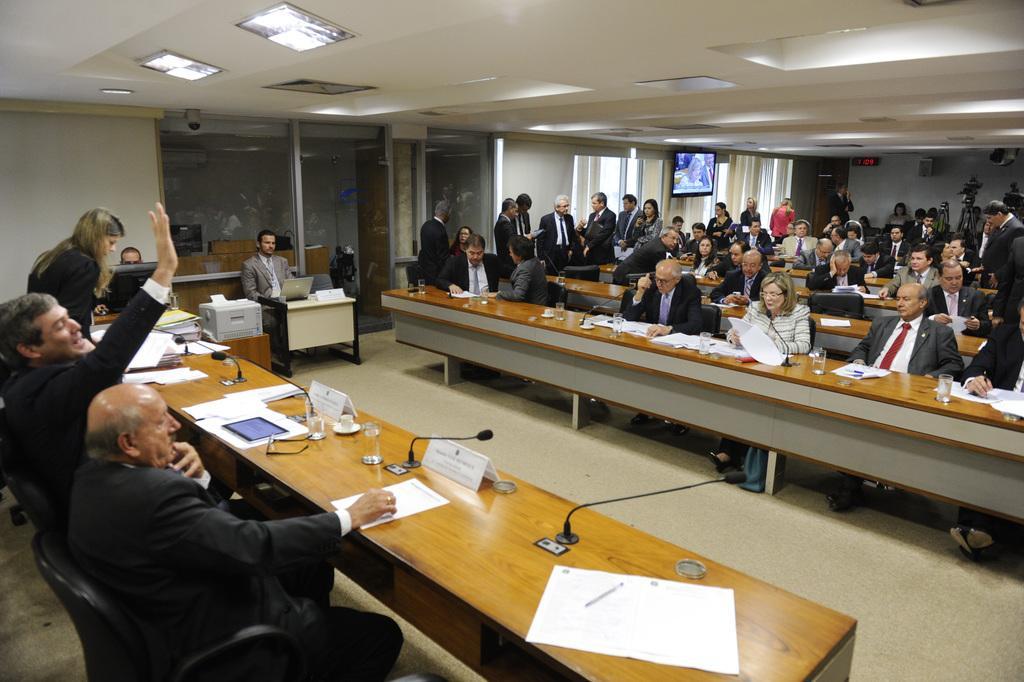Please provide a concise description of this image. In this image I can see five people are sitting in-front of the table and to the left. To the right there are group of people sitting and few are standing. On the table there are papers,glass and the boards. In the back there is a screen. 